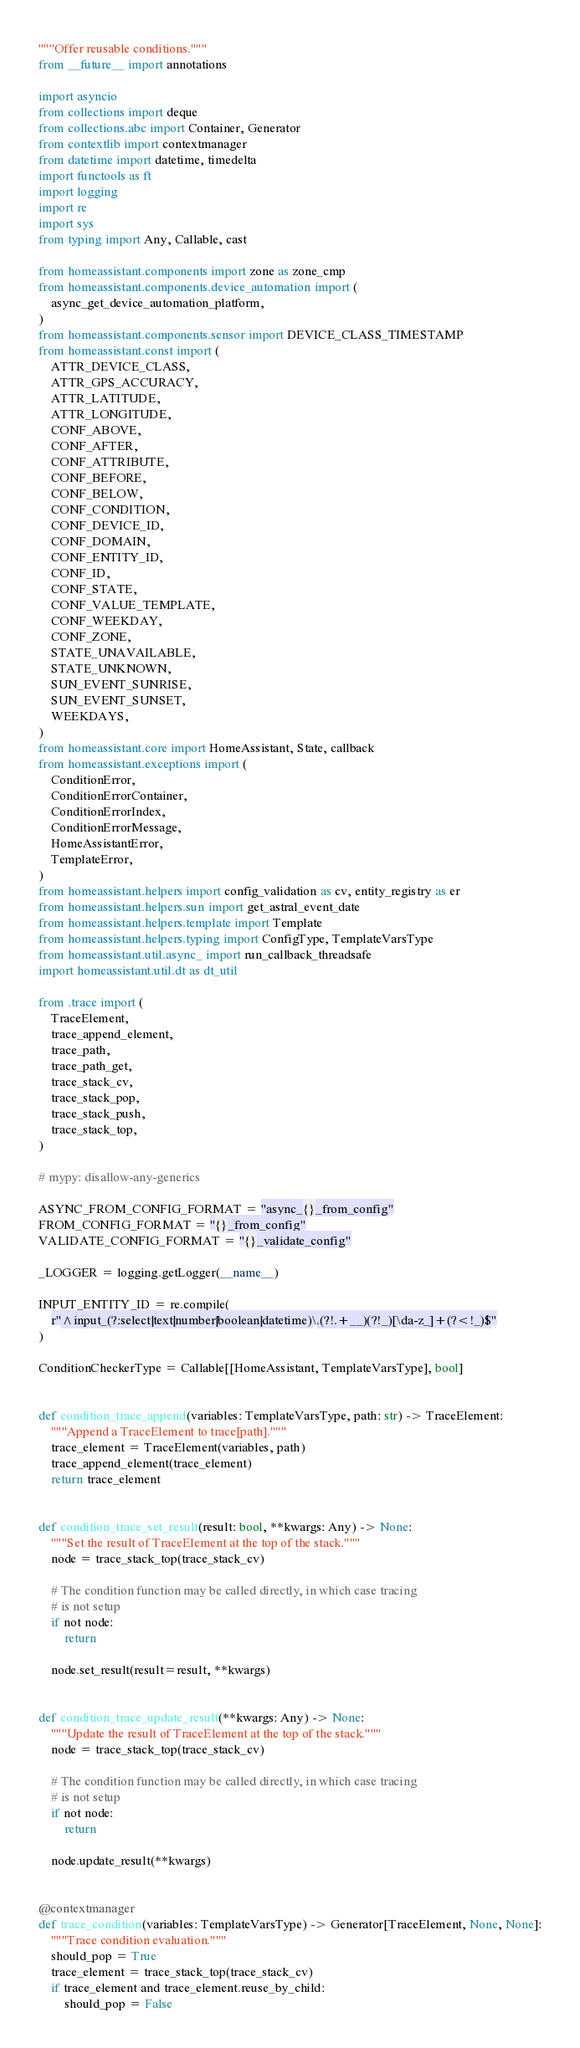Convert code to text. <code><loc_0><loc_0><loc_500><loc_500><_Python_>"""Offer reusable conditions."""
from __future__ import annotations

import asyncio
from collections import deque
from collections.abc import Container, Generator
from contextlib import contextmanager
from datetime import datetime, timedelta
import functools as ft
import logging
import re
import sys
from typing import Any, Callable, cast

from homeassistant.components import zone as zone_cmp
from homeassistant.components.device_automation import (
    async_get_device_automation_platform,
)
from homeassistant.components.sensor import DEVICE_CLASS_TIMESTAMP
from homeassistant.const import (
    ATTR_DEVICE_CLASS,
    ATTR_GPS_ACCURACY,
    ATTR_LATITUDE,
    ATTR_LONGITUDE,
    CONF_ABOVE,
    CONF_AFTER,
    CONF_ATTRIBUTE,
    CONF_BEFORE,
    CONF_BELOW,
    CONF_CONDITION,
    CONF_DEVICE_ID,
    CONF_DOMAIN,
    CONF_ENTITY_ID,
    CONF_ID,
    CONF_STATE,
    CONF_VALUE_TEMPLATE,
    CONF_WEEKDAY,
    CONF_ZONE,
    STATE_UNAVAILABLE,
    STATE_UNKNOWN,
    SUN_EVENT_SUNRISE,
    SUN_EVENT_SUNSET,
    WEEKDAYS,
)
from homeassistant.core import HomeAssistant, State, callback
from homeassistant.exceptions import (
    ConditionError,
    ConditionErrorContainer,
    ConditionErrorIndex,
    ConditionErrorMessage,
    HomeAssistantError,
    TemplateError,
)
from homeassistant.helpers import config_validation as cv, entity_registry as er
from homeassistant.helpers.sun import get_astral_event_date
from homeassistant.helpers.template import Template
from homeassistant.helpers.typing import ConfigType, TemplateVarsType
from homeassistant.util.async_ import run_callback_threadsafe
import homeassistant.util.dt as dt_util

from .trace import (
    TraceElement,
    trace_append_element,
    trace_path,
    trace_path_get,
    trace_stack_cv,
    trace_stack_pop,
    trace_stack_push,
    trace_stack_top,
)

# mypy: disallow-any-generics

ASYNC_FROM_CONFIG_FORMAT = "async_{}_from_config"
FROM_CONFIG_FORMAT = "{}_from_config"
VALIDATE_CONFIG_FORMAT = "{}_validate_config"

_LOGGER = logging.getLogger(__name__)

INPUT_ENTITY_ID = re.compile(
    r"^input_(?:select|text|number|boolean|datetime)\.(?!.+__)(?!_)[\da-z_]+(?<!_)$"
)

ConditionCheckerType = Callable[[HomeAssistant, TemplateVarsType], bool]


def condition_trace_append(variables: TemplateVarsType, path: str) -> TraceElement:
    """Append a TraceElement to trace[path]."""
    trace_element = TraceElement(variables, path)
    trace_append_element(trace_element)
    return trace_element


def condition_trace_set_result(result: bool, **kwargs: Any) -> None:
    """Set the result of TraceElement at the top of the stack."""
    node = trace_stack_top(trace_stack_cv)

    # The condition function may be called directly, in which case tracing
    # is not setup
    if not node:
        return

    node.set_result(result=result, **kwargs)


def condition_trace_update_result(**kwargs: Any) -> None:
    """Update the result of TraceElement at the top of the stack."""
    node = trace_stack_top(trace_stack_cv)

    # The condition function may be called directly, in which case tracing
    # is not setup
    if not node:
        return

    node.update_result(**kwargs)


@contextmanager
def trace_condition(variables: TemplateVarsType) -> Generator[TraceElement, None, None]:
    """Trace condition evaluation."""
    should_pop = True
    trace_element = trace_stack_top(trace_stack_cv)
    if trace_element and trace_element.reuse_by_child:
        should_pop = False</code> 